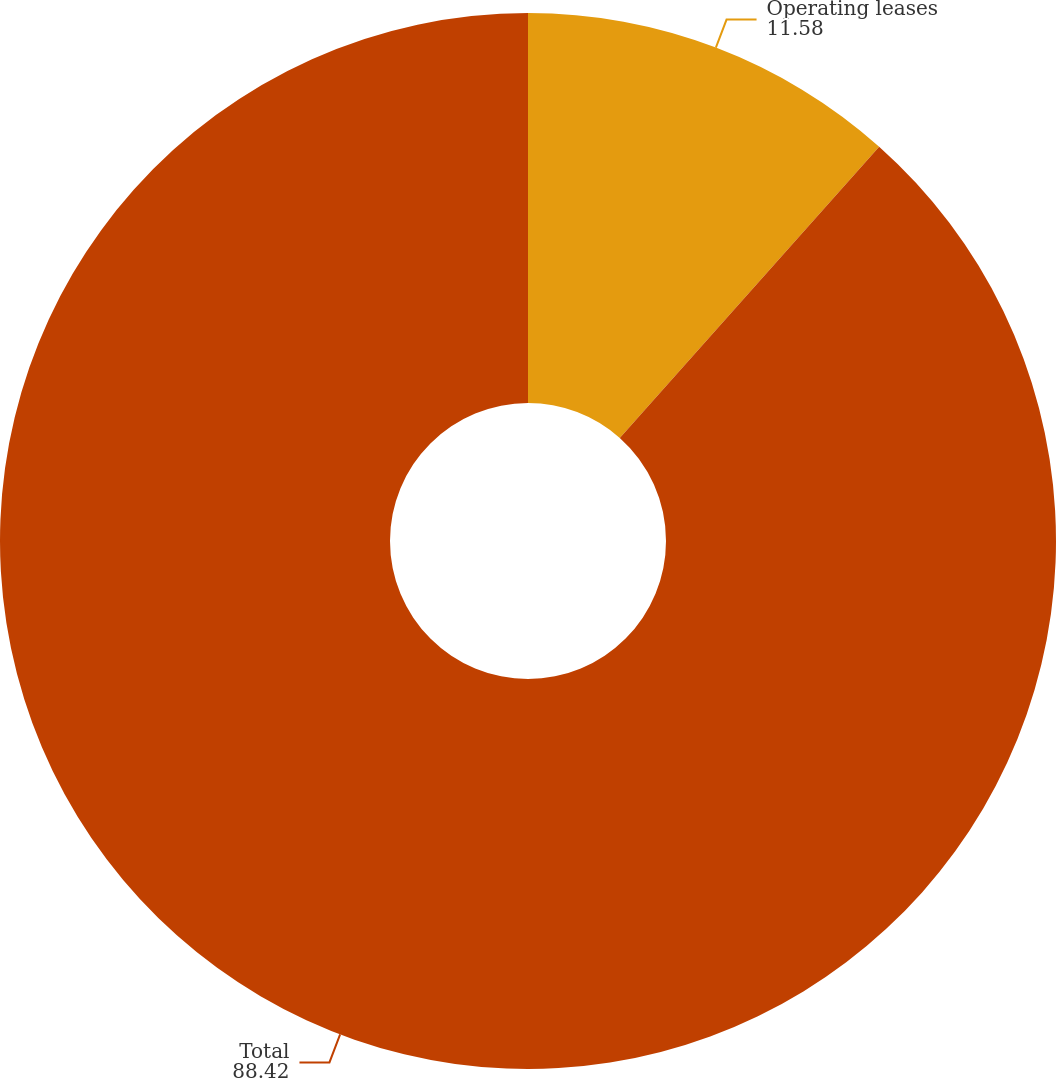Convert chart to OTSL. <chart><loc_0><loc_0><loc_500><loc_500><pie_chart><fcel>Operating leases<fcel>Total<nl><fcel>11.58%<fcel>88.42%<nl></chart> 